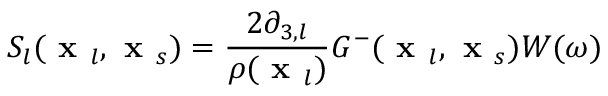<formula> <loc_0><loc_0><loc_500><loc_500>S _ { l } ( x _ { l } , x _ { s } ) = \frac { 2 \partial _ { 3 , l } } { \rho ( x _ { l } ) } G ^ { - } ( x _ { l } , x _ { s } ) W ( \omega )</formula> 